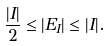Convert formula to latex. <formula><loc_0><loc_0><loc_500><loc_500>\frac { | I | } { 2 } \leq | E _ { I } | \leq | I | .</formula> 